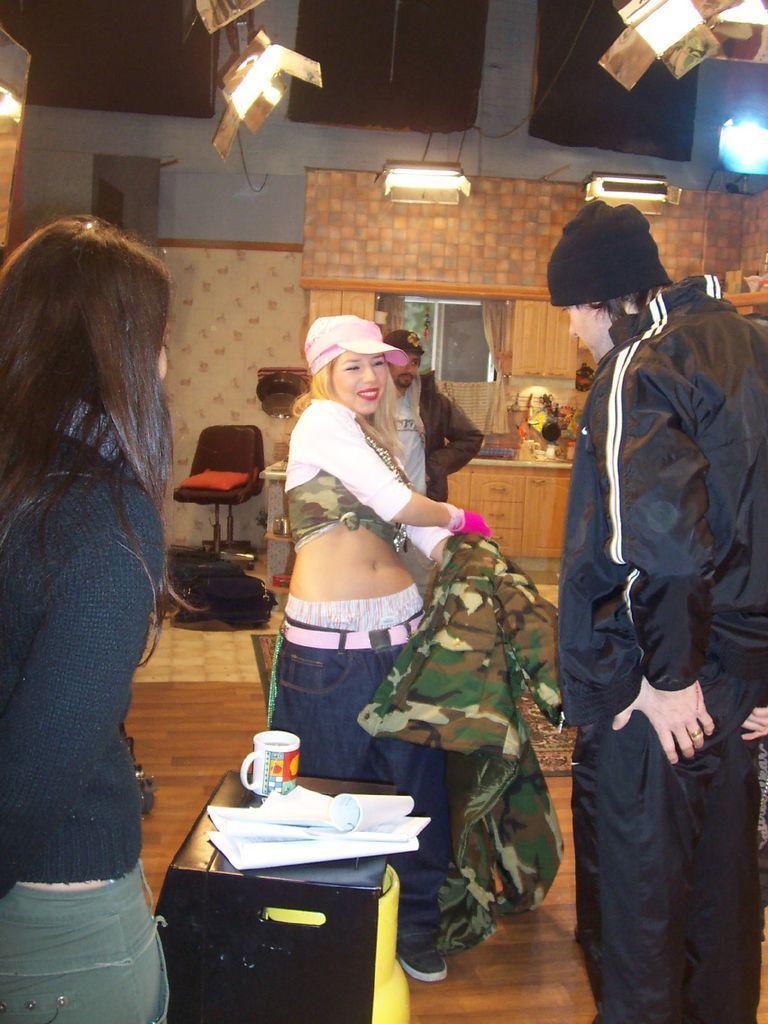Could you give a brief overview of what you see in this image? In the image I can see a place where we have a person who is wearing the dress and some other people and a table on which there are some things placed and also I can see some lights to the roof. 